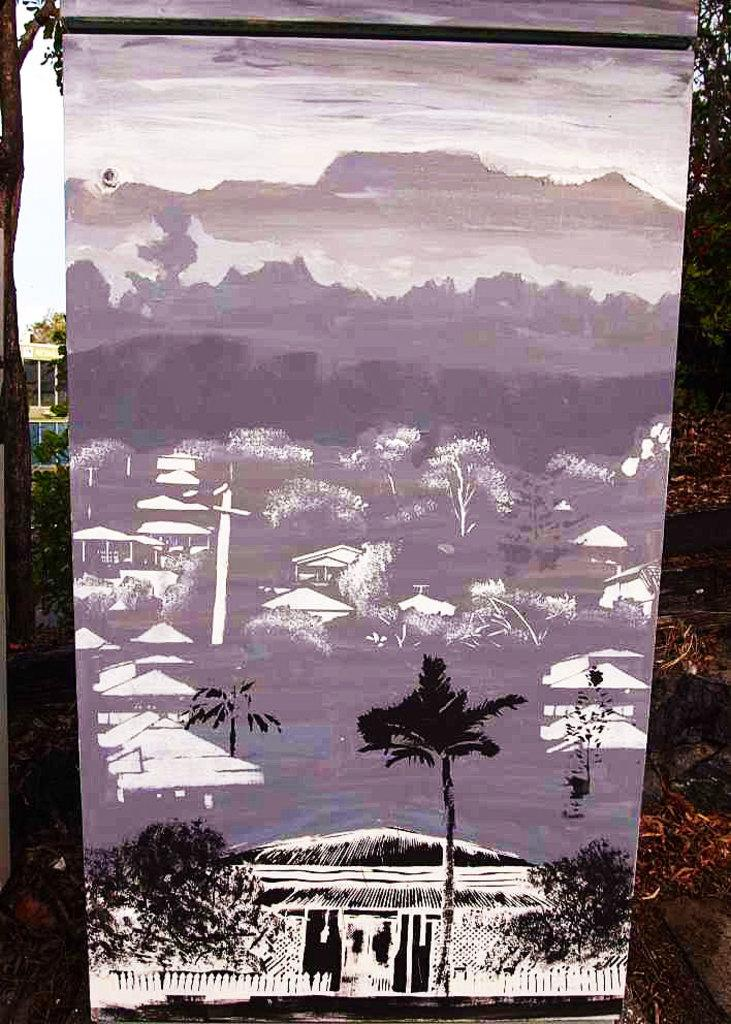What type of natural elements can be seen in the image? There are trees in the image. What type of man-made structures are present in the image? There are houses in the image. What object can be seen standing upright in the image? There is a pole in the image. What can be seen in the distance in the image? There are hills visible in the background of the image. What is visible in the sky in the background of the image? There is a sky with clouds in the background of the image. What type of reaction does the pencil have when it sees the point in the image? There is no pencil or point present in the image, so this question cannot be answered. 